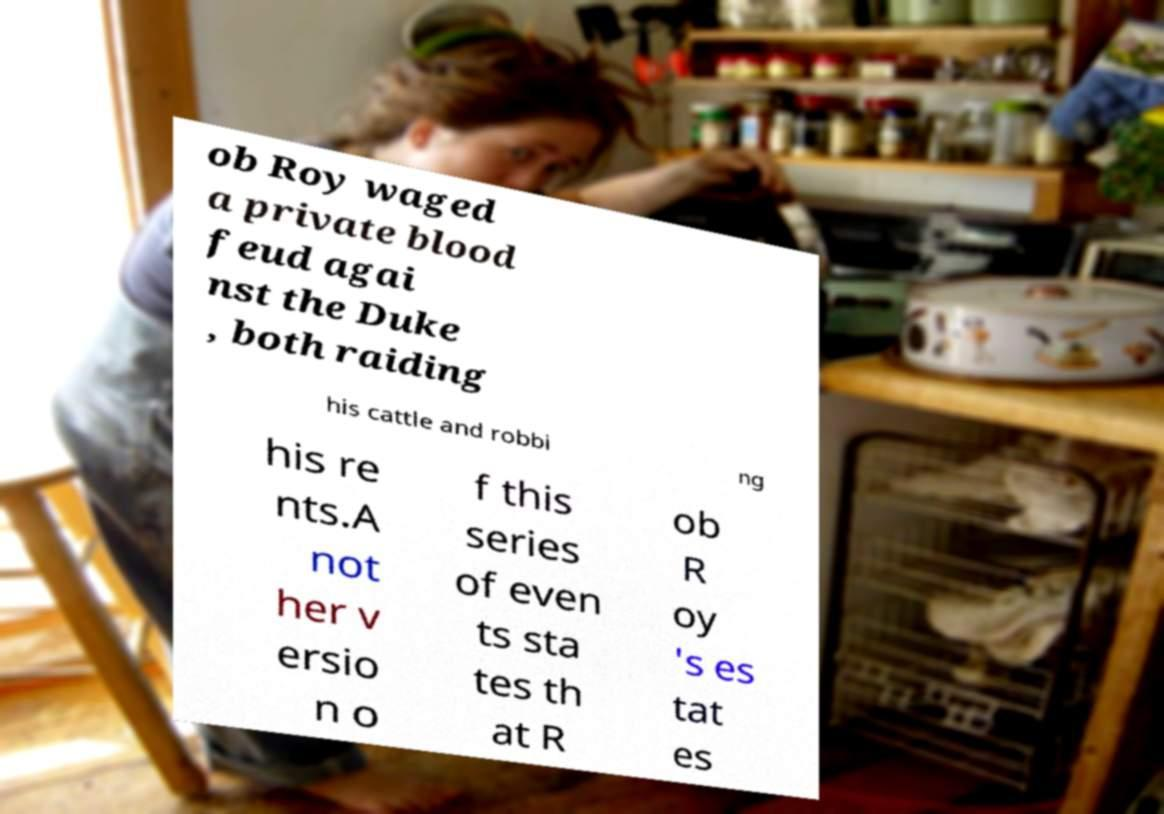I need the written content from this picture converted into text. Can you do that? ob Roy waged a private blood feud agai nst the Duke , both raiding his cattle and robbi ng his re nts.A not her v ersio n o f this series of even ts sta tes th at R ob R oy 's es tat es 